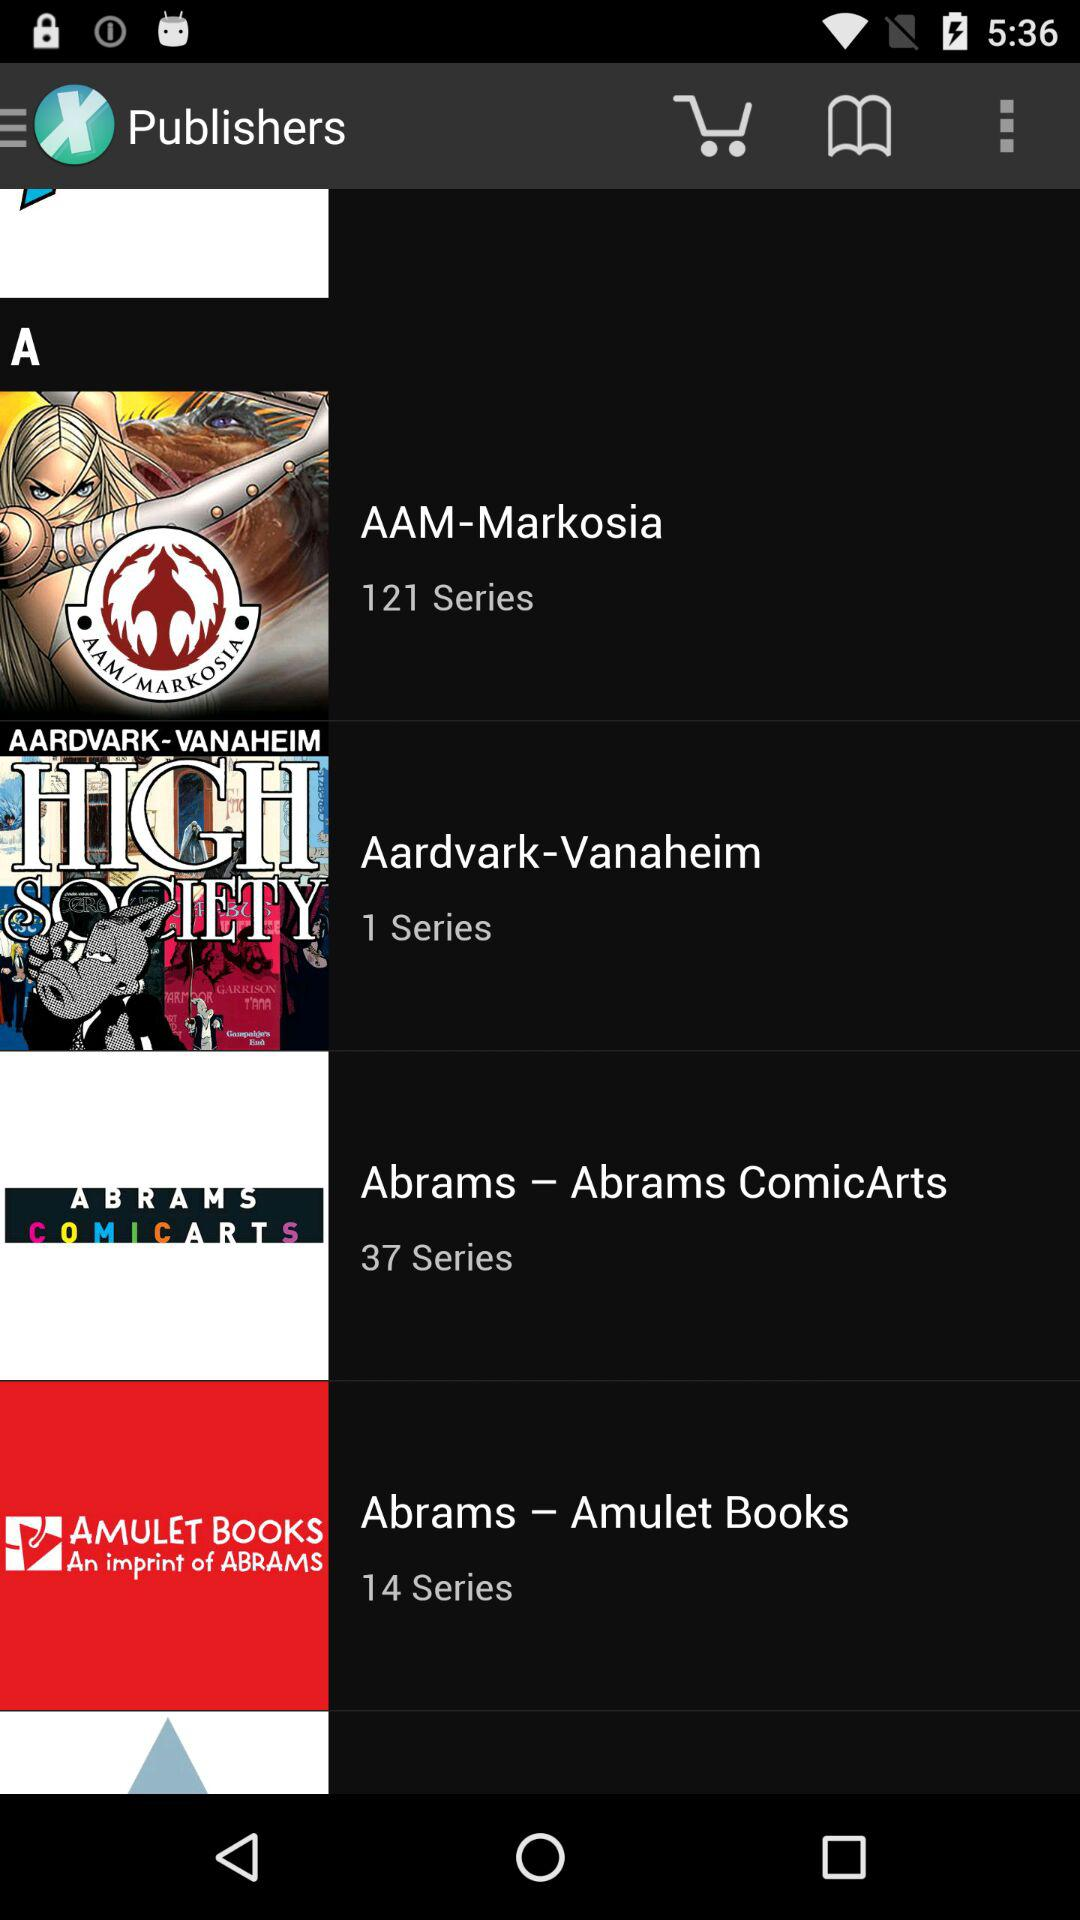What is the name of the publisher who has published 121 series? The name of the publisher is "AAM-Markosia". 